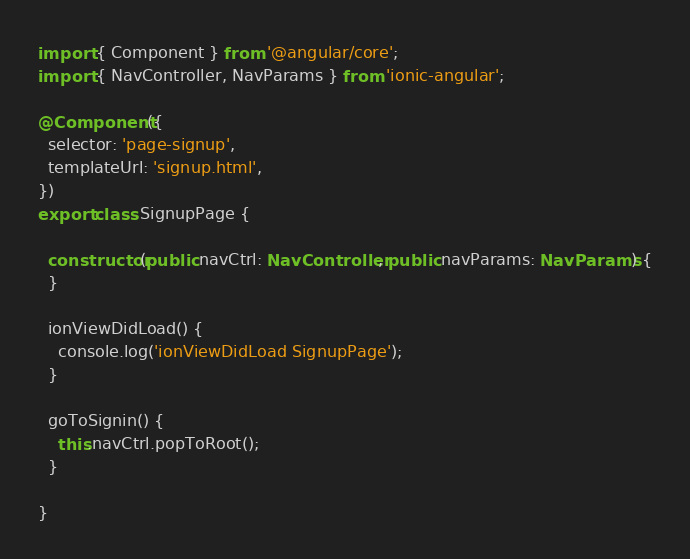Convert code to text. <code><loc_0><loc_0><loc_500><loc_500><_TypeScript_>import { Component } from '@angular/core';
import { NavController, NavParams } from 'ionic-angular';

@Component({
  selector: 'page-signup',
  templateUrl: 'signup.html',
})
export class SignupPage {

  constructor(public navCtrl: NavController, public navParams: NavParams) {
  }

  ionViewDidLoad() {
    console.log('ionViewDidLoad SignupPage');
  }

  goToSignin() {
    this.navCtrl.popToRoot();
  }

}
</code> 